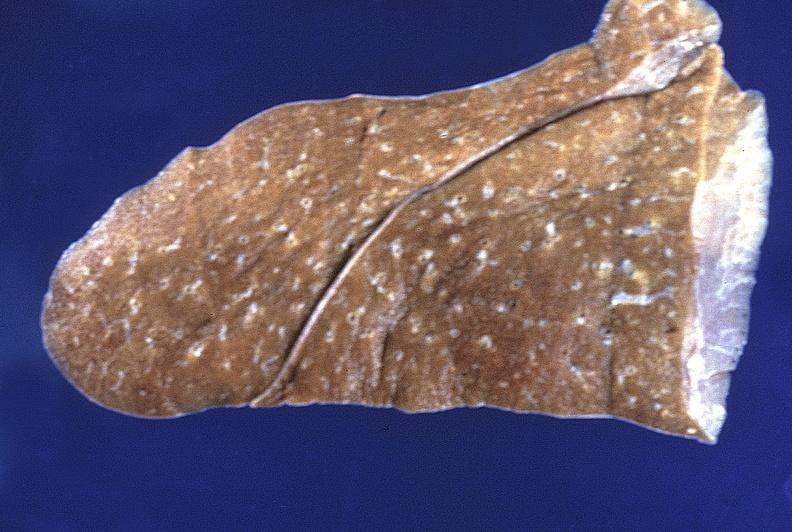where is this?
Answer the question using a single word or phrase. Lung 